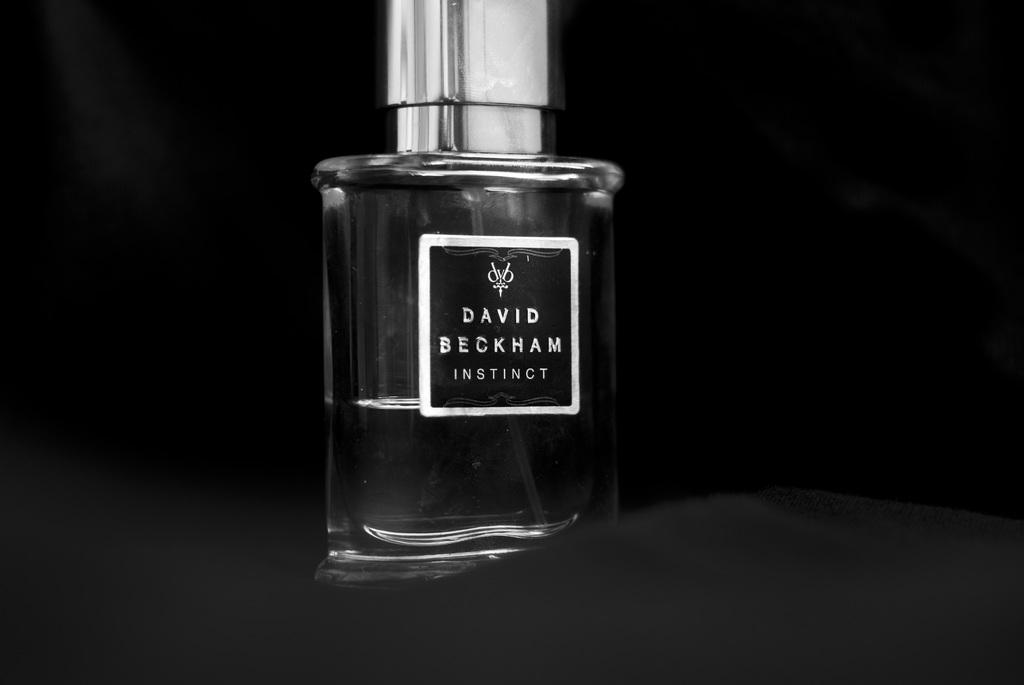What is the main object in the image? There is a perfume bottle in the image. What is written on the perfume bottle? The perfume bottle has "David Beckham" written on it. What color is the background of the image? The background of the image is black. What type of apples can be seen in the image? There are no apples present in the image. 